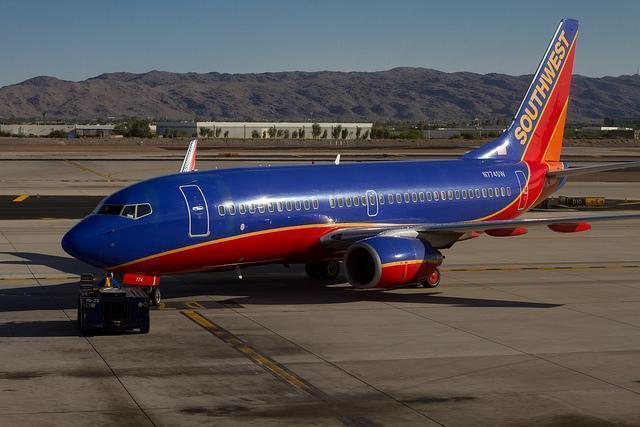Where is the plane stopped?
Choose the correct response, then elucidate: 'Answer: answer
Rationale: rationale.'
Options: Road, driveway, tarmac, roof top. Answer: tarmac.
Rationale: The tarmac is where planes go to land and drive around to a terminal. 